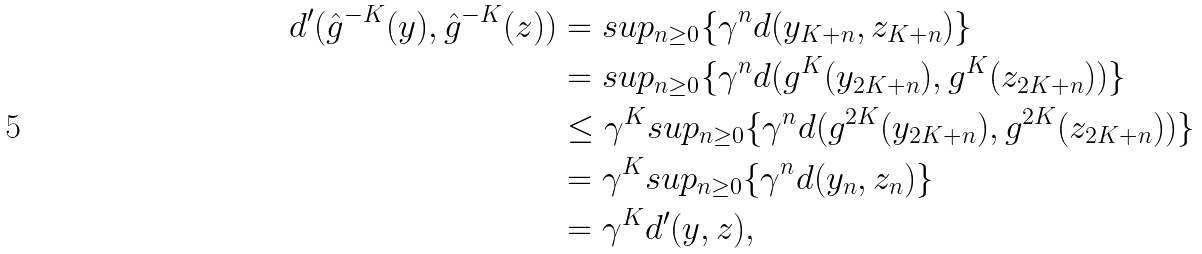Convert formula to latex. <formula><loc_0><loc_0><loc_500><loc_500>d ^ { \prime } ( \hat { g } ^ { - K } ( y ) , \hat { g } ^ { - K } ( z ) ) & = s u p _ { n \geq 0 } \{ \gamma ^ { n } d ( y _ { K + n } , z _ { K + n } ) \} \\ & = s u p _ { n \geq 0 } \{ \gamma ^ { n } d ( g ^ { K } ( y _ { 2 K + n } ) , g ^ { K } ( z _ { 2 K + n } ) ) \} \\ & \leq \gamma ^ { K } s u p _ { n \geq 0 } \{ \gamma ^ { n } d ( g ^ { 2 K } ( y _ { 2 K + n } ) , g ^ { 2 K } ( z _ { 2 K + n } ) ) \} \\ & = \gamma ^ { K } s u p _ { n \geq 0 } \{ \gamma ^ { n } d ( y _ { n } , z _ { n } ) \} \\ & = \gamma ^ { K } d ^ { \prime } ( y , z ) ,</formula> 